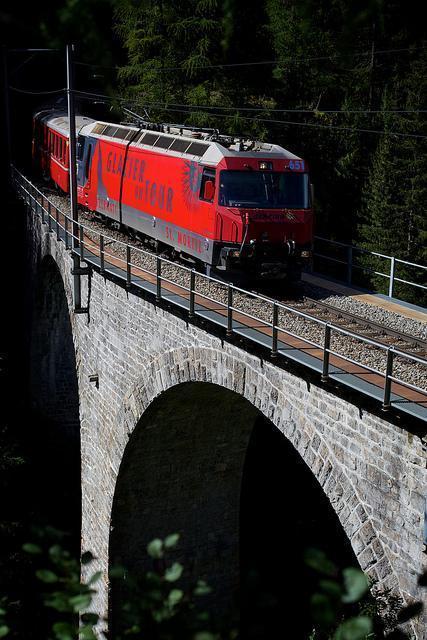How many people are holding tennis balls in the picture?
Give a very brief answer. 0. 